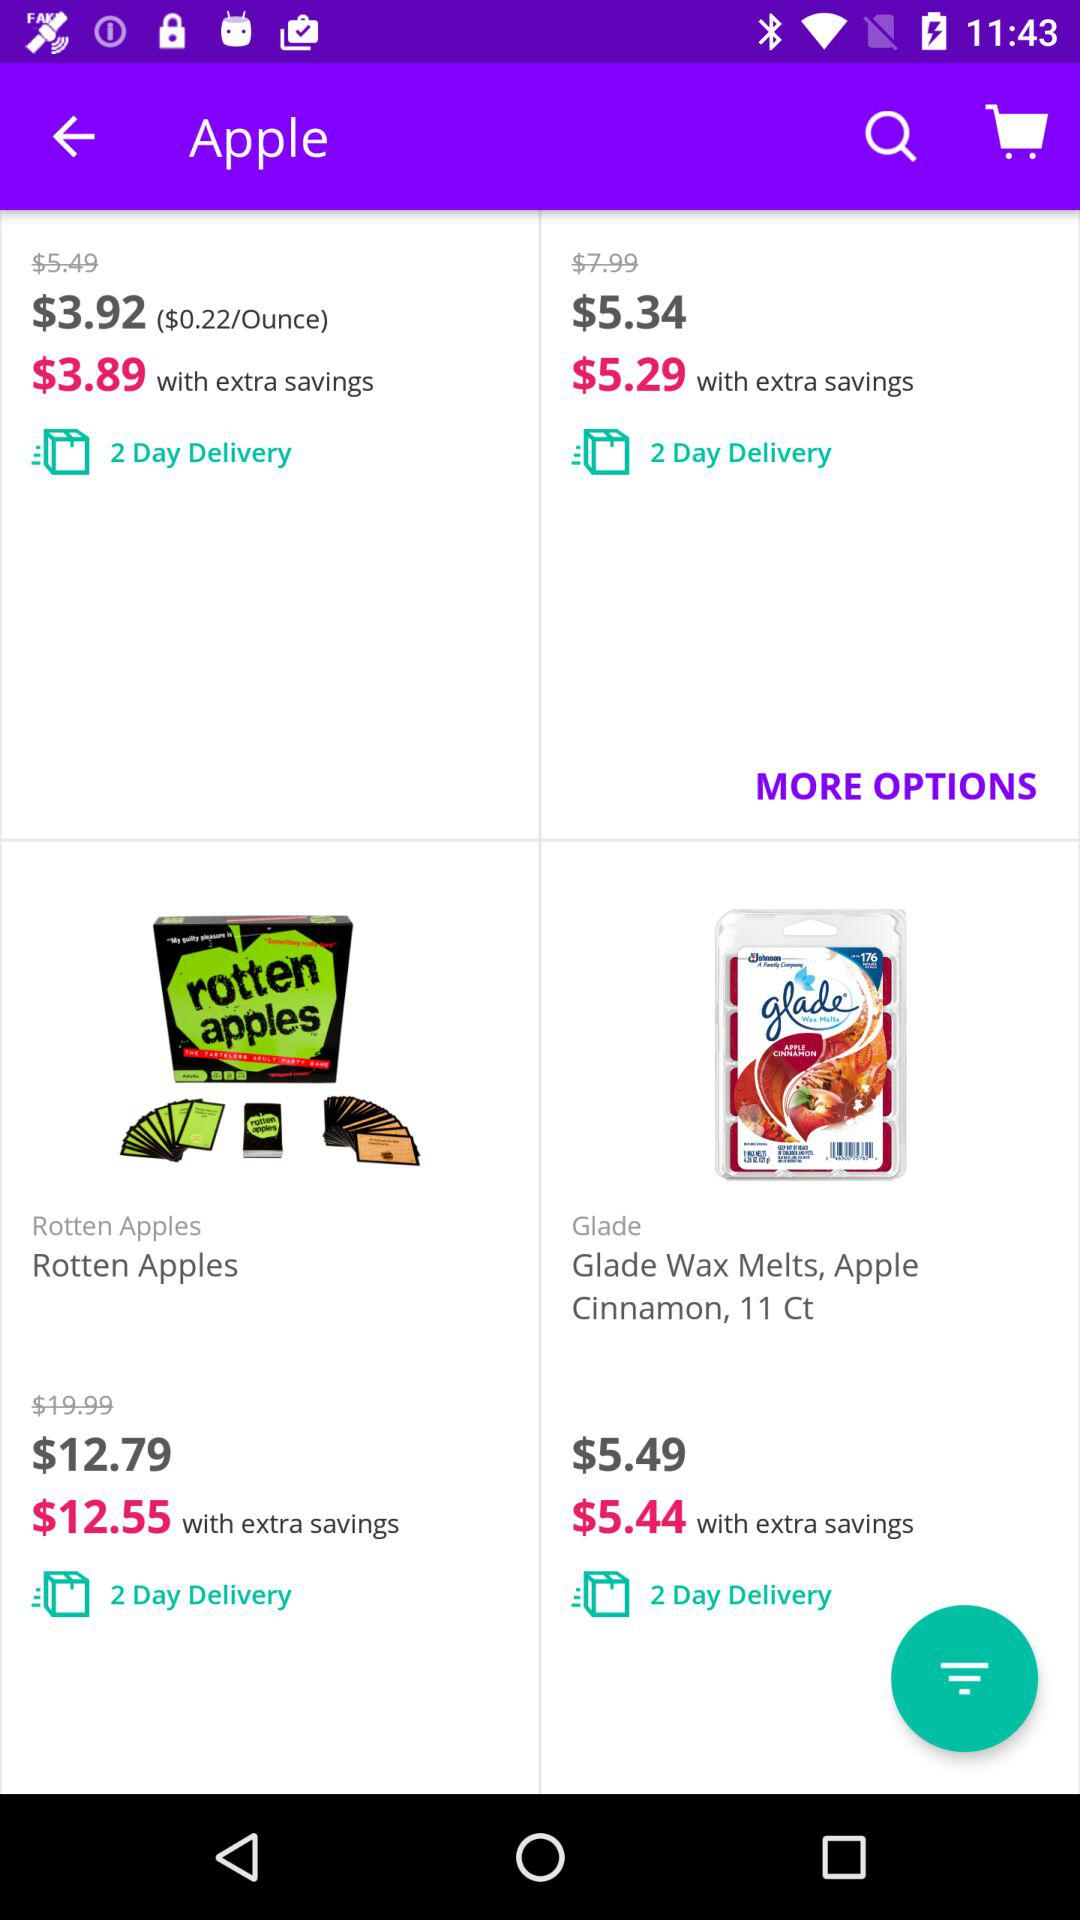How many days will it take to deliver rotten apples? It will take 2 days to deliver. 